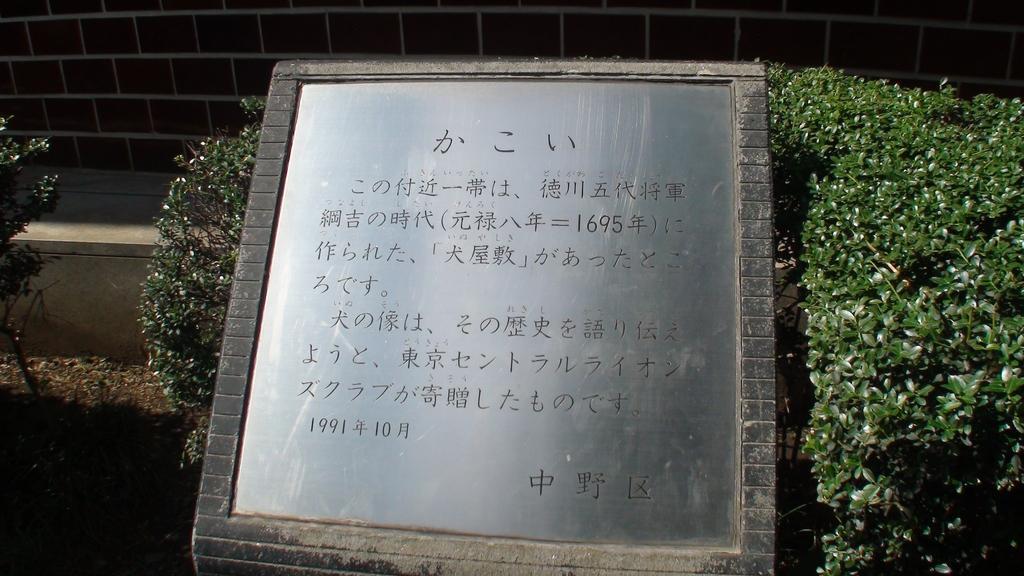Please provide a concise description of this image. In this picture I can observe a memorial in the middle of the picture. On either sides of the memorial I can observe plants. In the background I can observe wall. 